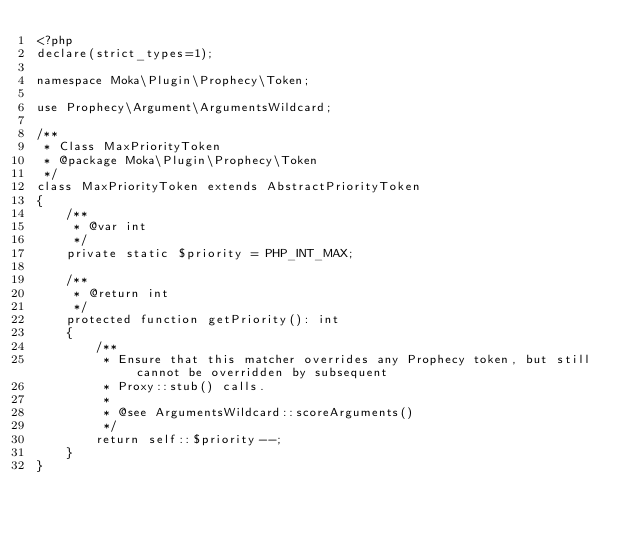Convert code to text. <code><loc_0><loc_0><loc_500><loc_500><_PHP_><?php
declare(strict_types=1);

namespace Moka\Plugin\Prophecy\Token;

use Prophecy\Argument\ArgumentsWildcard;

/**
 * Class MaxPriorityToken
 * @package Moka\Plugin\Prophecy\Token
 */
class MaxPriorityToken extends AbstractPriorityToken
{
    /**
     * @var int
     */
    private static $priority = PHP_INT_MAX;

    /**
     * @return int
     */
    protected function getPriority(): int
    {
        /**
         * Ensure that this matcher overrides any Prophecy token, but still cannot be overridden by subsequent
         * Proxy::stub() calls.
         *
         * @see ArgumentsWildcard::scoreArguments()
         */
        return self::$priority--;
    }
}
</code> 